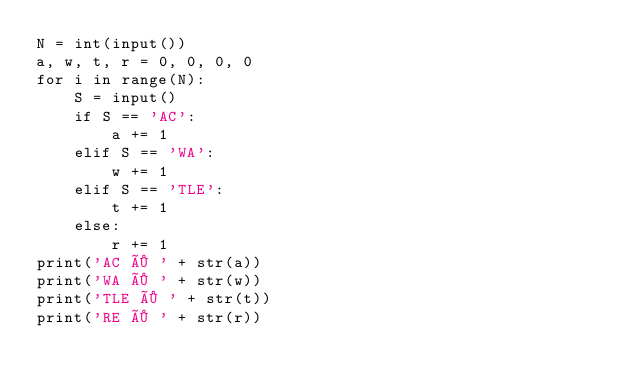Convert code to text. <code><loc_0><loc_0><loc_500><loc_500><_Python_>N = int(input())
a, w, t, r = 0, 0, 0, 0
for i in range(N):
    S = input()
    if S == 'AC':
        a += 1
    elif S == 'WA':
        w += 1
    elif S == 'TLE':
        t += 1
    else:
        r += 1
print('AC × ' + str(a))
print('WA × ' + str(w))
print('TLE × ' + str(t))
print('RE × ' + str(r))</code> 